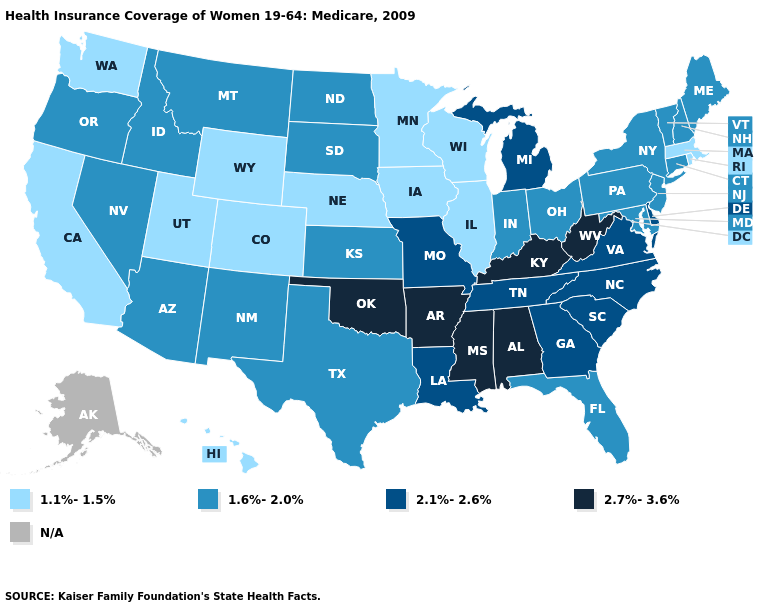Name the states that have a value in the range 2.1%-2.6%?
Quick response, please. Delaware, Georgia, Louisiana, Michigan, Missouri, North Carolina, South Carolina, Tennessee, Virginia. Does Florida have the lowest value in the South?
Write a very short answer. Yes. What is the value of Wyoming?
Write a very short answer. 1.1%-1.5%. Name the states that have a value in the range N/A?
Quick response, please. Alaska. What is the lowest value in states that border New York?
Give a very brief answer. 1.1%-1.5%. What is the value of Iowa?
Quick response, please. 1.1%-1.5%. What is the value of Massachusetts?
Answer briefly. 1.1%-1.5%. What is the lowest value in the Northeast?
Be succinct. 1.1%-1.5%. Among the states that border Connecticut , which have the lowest value?
Write a very short answer. Massachusetts, Rhode Island. What is the value of Delaware?
Quick response, please. 2.1%-2.6%. What is the lowest value in the MidWest?
Concise answer only. 1.1%-1.5%. Which states hav the highest value in the South?
Keep it brief. Alabama, Arkansas, Kentucky, Mississippi, Oklahoma, West Virginia. What is the value of Arkansas?
Give a very brief answer. 2.7%-3.6%. What is the lowest value in states that border New Jersey?
Quick response, please. 1.6%-2.0%. What is the value of New York?
Short answer required. 1.6%-2.0%. 